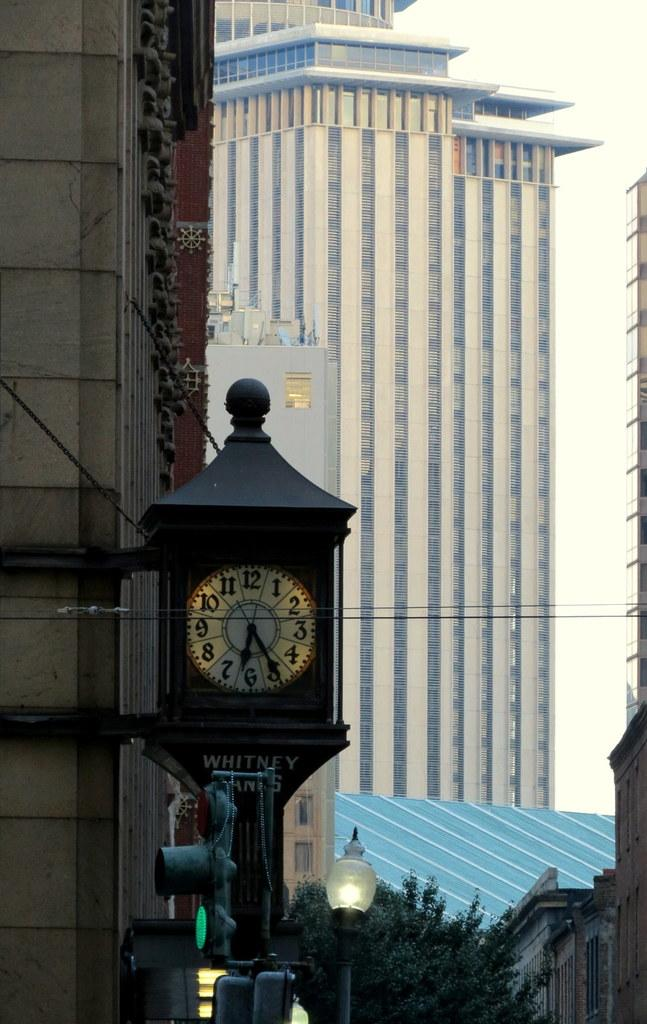<image>
Create a compact narrative representing the image presented. An old fashioned clock set at twenty five past six 